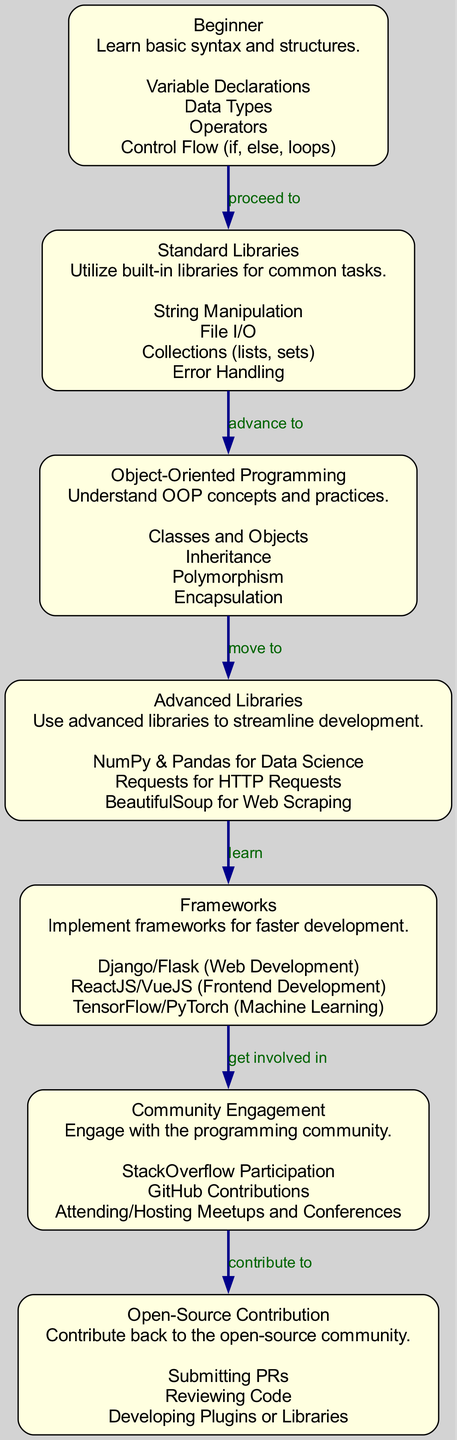What is the first milestone in the programming language learning path? The first milestone mentioned in the diagram is "Beginner." This node is the starting point leading to the next stages of learning in the diagram.
Answer: Beginner How many nodes are there in the diagram? The diagram includes a total of six nodes: Beginner, Standard Libraries, Object-Oriented Programming, Advanced Libraries, Frameworks, Community Engagement, and Open-Source Contribution. After counting each of these nodes, the total comes to six.
Answer: 6 What is the relationship between "Advanced Libraries" and "Frameworks"? The diagram indicates that the relationship is one of learning, with an edge labeled "learn" pointing from "Advanced Libraries" to "Frameworks." This suggests that after mastering advanced libraries, one is expected to learn different frameworks.
Answer: learn What comes after "Community Engagement" in the learning path? According to the diagram, after "Community Engagement," the next milestone is "Open-Source Contribution." This shows progression in the learning path where engaging with the community leads to contributions in open-source projects.
Answer: Open-Source Contribution Which node includes concepts related to classes and objects? The node labeled "Object-Oriented Programming" contains the concepts related to classes and objects. This node emphasizes understanding OOP principles, which are fundamental in modern programming paradigms.
Answer: Object-Oriented Programming What is the last step in the learning path? The last step in the learning path, based on the diagram, is "Open-Source Contribution," indicating that contributing back to open-source projects is the culmination of this learning journey.
Answer: Open-Source Contribution How do you progress from "Standard Libraries" to "Object-Oriented Programming"? The diagram outlines a direct progression from "Standard Libraries" to "Object-Oriented Programming" indicated by the edge labeled "advance to." This means that after achieving proficiency in standard libraries, one advances to learning OOP concepts.
Answer: advance to Identify the category under which "Django" falls. "Django" is mentioned under the node labeled "Frameworks." This category focuses on using frameworks to facilitate faster development processes in programming, particularly web development.
Answer: Frameworks 